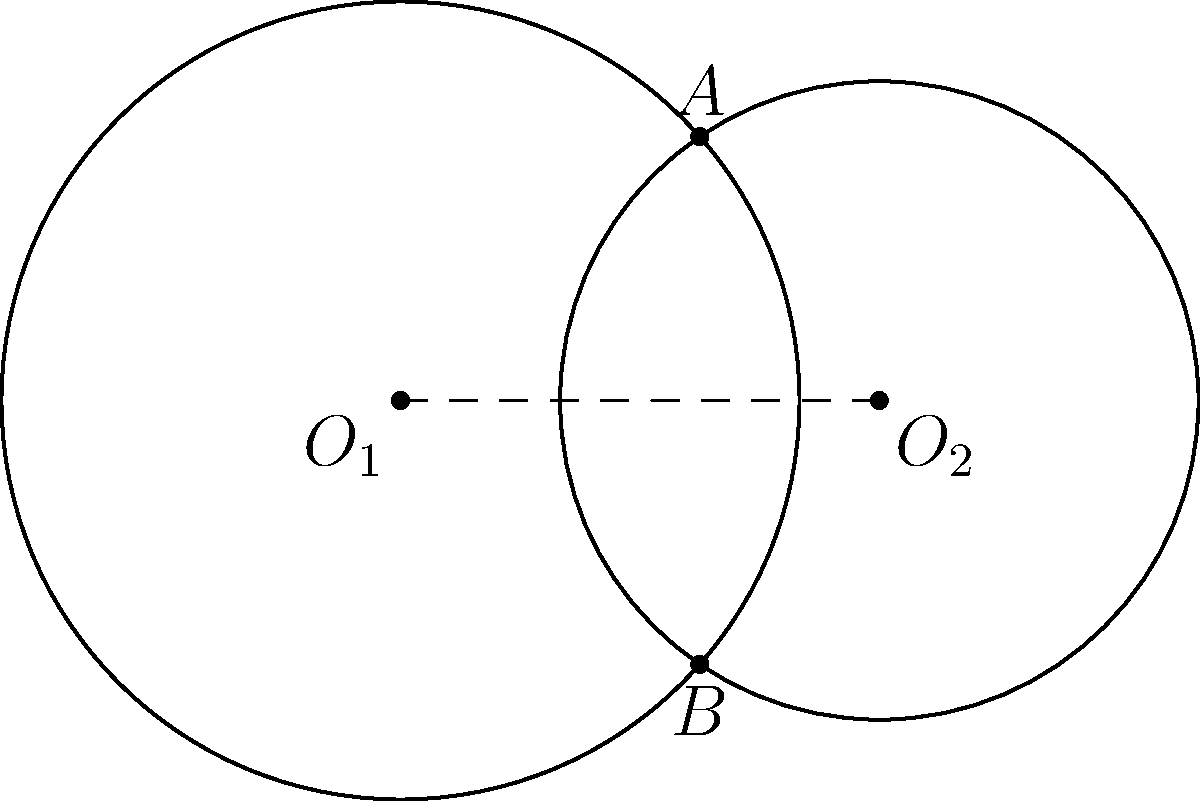In a real-time bidding system, two circular advertising zones overlap. The centers of these zones, $O_1$ and $O_2$, are 3 units apart. Zone 1 has a radius of 2.5 units, while Zone 2 has a radius of 2 units. Calculate the area of the overlapping region to optimize ad placement. Round your answer to two decimal places. To solve this problem, we'll use the formula for the area of intersection of two circles:

1) First, calculate the distance $d$ between the centers:
   $d = 3$ (given in the problem)

2) The radii are $r_1 = 2.5$ and $r_2 = 2$

3) Calculate the angles $\theta_1$ and $\theta_2$:
   $\theta_1 = 2 \arccos(\frac{d^2 + r_1^2 - r_2^2}{2dr_1})$
   $\theta_2 = 2 \arccos(\frac{d^2 + r_2^2 - r_1^2}{2dr_2})$

4) Calculate $\theta_1$:
   $\theta_1 = 2 \arccos(\frac{3^2 + 2.5^2 - 2^2}{2 \cdot 3 \cdot 2.5}) = 2.214$ radians

5) Calculate $\theta_2$:
   $\theta_2 = 2 \arccos(\frac{3^2 + 2^2 - 2.5^2}{2 \cdot 3 \cdot 2}) = 2.726$ radians

6) The area of intersection is given by:
   $A = \frac{1}{2}r_1^2(\theta_1 - \sin\theta_1) + \frac{1}{2}r_2^2(\theta_2 - \sin\theta_2)$

7) Substitute the values:
   $A = \frac{1}{2}(2.5)^2(2.214 - \sin(2.214)) + \frac{1}{2}(2)^2(2.726 - \sin(2.726))$

8) Calculate:
   $A = 3.1416 + 2.3478 = 5.4894$ square units

9) Rounding to two decimal places:
   $A \approx 5.49$ square units
Answer: 5.49 square units 